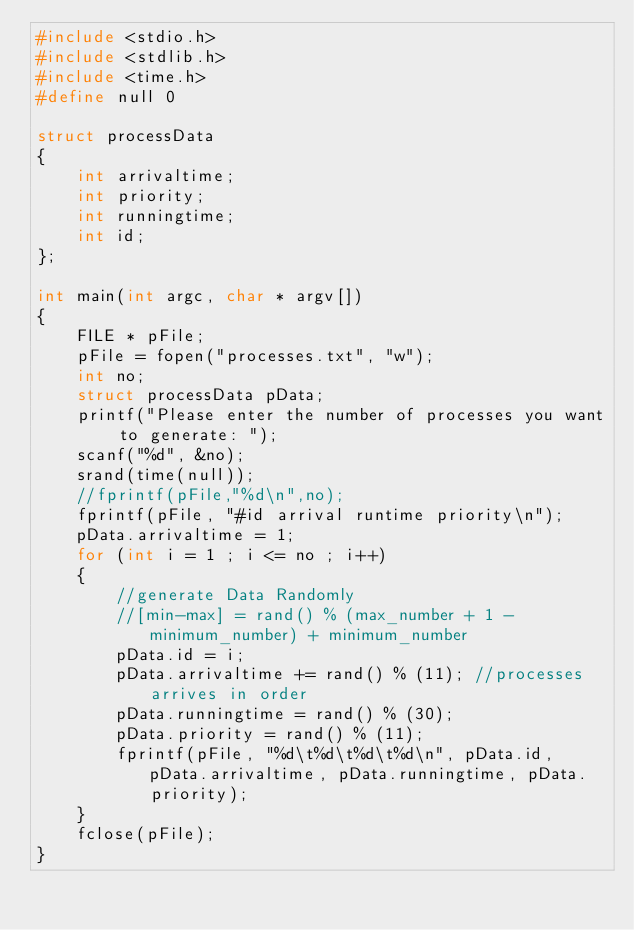<code> <loc_0><loc_0><loc_500><loc_500><_C_>#include <stdio.h>
#include <stdlib.h>
#include <time.h>
#define null 0

struct processData
{
    int arrivaltime;
    int priority;
    int runningtime;
    int id;
};

int main(int argc, char * argv[])
{
    FILE * pFile;
    pFile = fopen("processes.txt", "w");
    int no;
    struct processData pData;
    printf("Please enter the number of processes you want to generate: ");
    scanf("%d", &no);
    srand(time(null));
    //fprintf(pFile,"%d\n",no);
    fprintf(pFile, "#id arrival runtime priority\n");
    pData.arrivaltime = 1;
    for (int i = 1 ; i <= no ; i++)
    {
        //generate Data Randomly
        //[min-max] = rand() % (max_number + 1 - minimum_number) + minimum_number
        pData.id = i;
        pData.arrivaltime += rand() % (11); //processes arrives in order
        pData.runningtime = rand() % (30);
        pData.priority = rand() % (11);
        fprintf(pFile, "%d\t%d\t%d\t%d\n", pData.id, pData.arrivaltime, pData.runningtime, pData.priority);
    }
    fclose(pFile);
}
</code> 